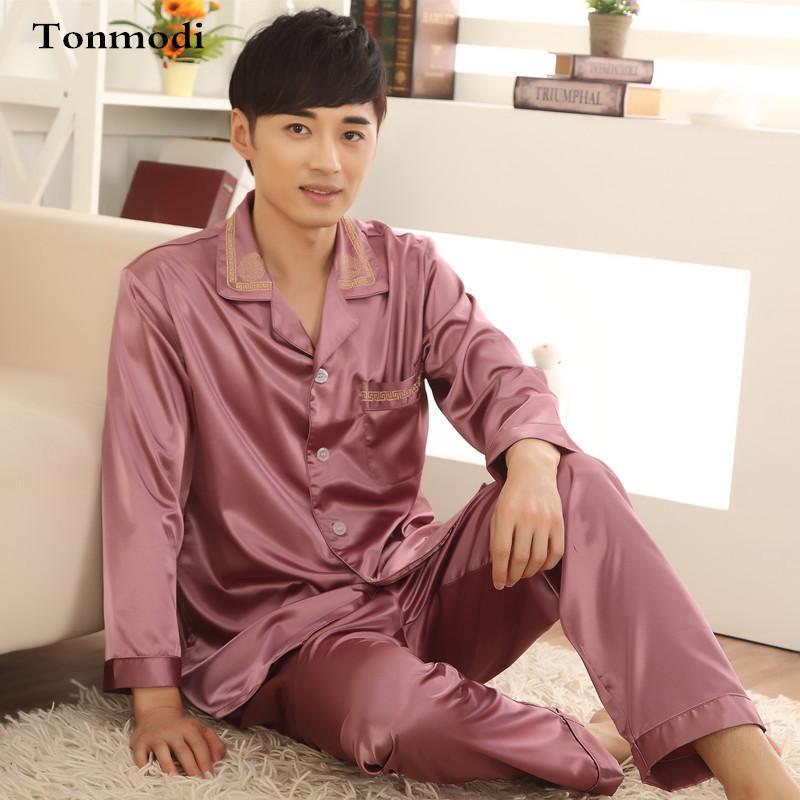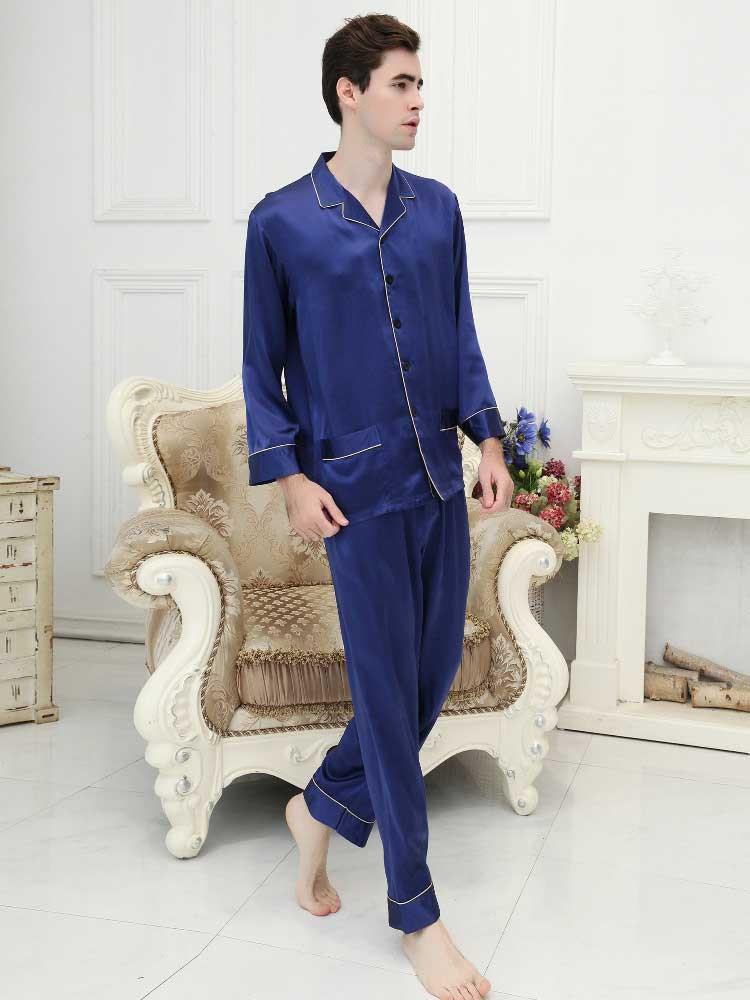The first image is the image on the left, the second image is the image on the right. For the images displayed, is the sentence "There are no pieces of furniture in the background of these images." factually correct? Answer yes or no. No. The first image is the image on the left, the second image is the image on the right. For the images displayed, is the sentence "In one image, a man wearing solid color silky pajamas with cuffs on both shirt and pants is standing with one foot forward." factually correct? Answer yes or no. Yes. 